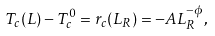Convert formula to latex. <formula><loc_0><loc_0><loc_500><loc_500>T _ { c } ( L ) - T _ { c } ^ { 0 } = r _ { c } ( L _ { R } ) = - A L _ { R } ^ { - \phi } ,</formula> 